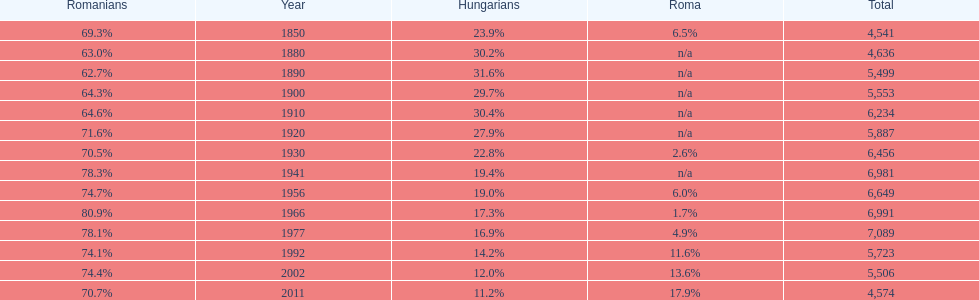In what year was there the largest percentage of hungarians? 1890. 